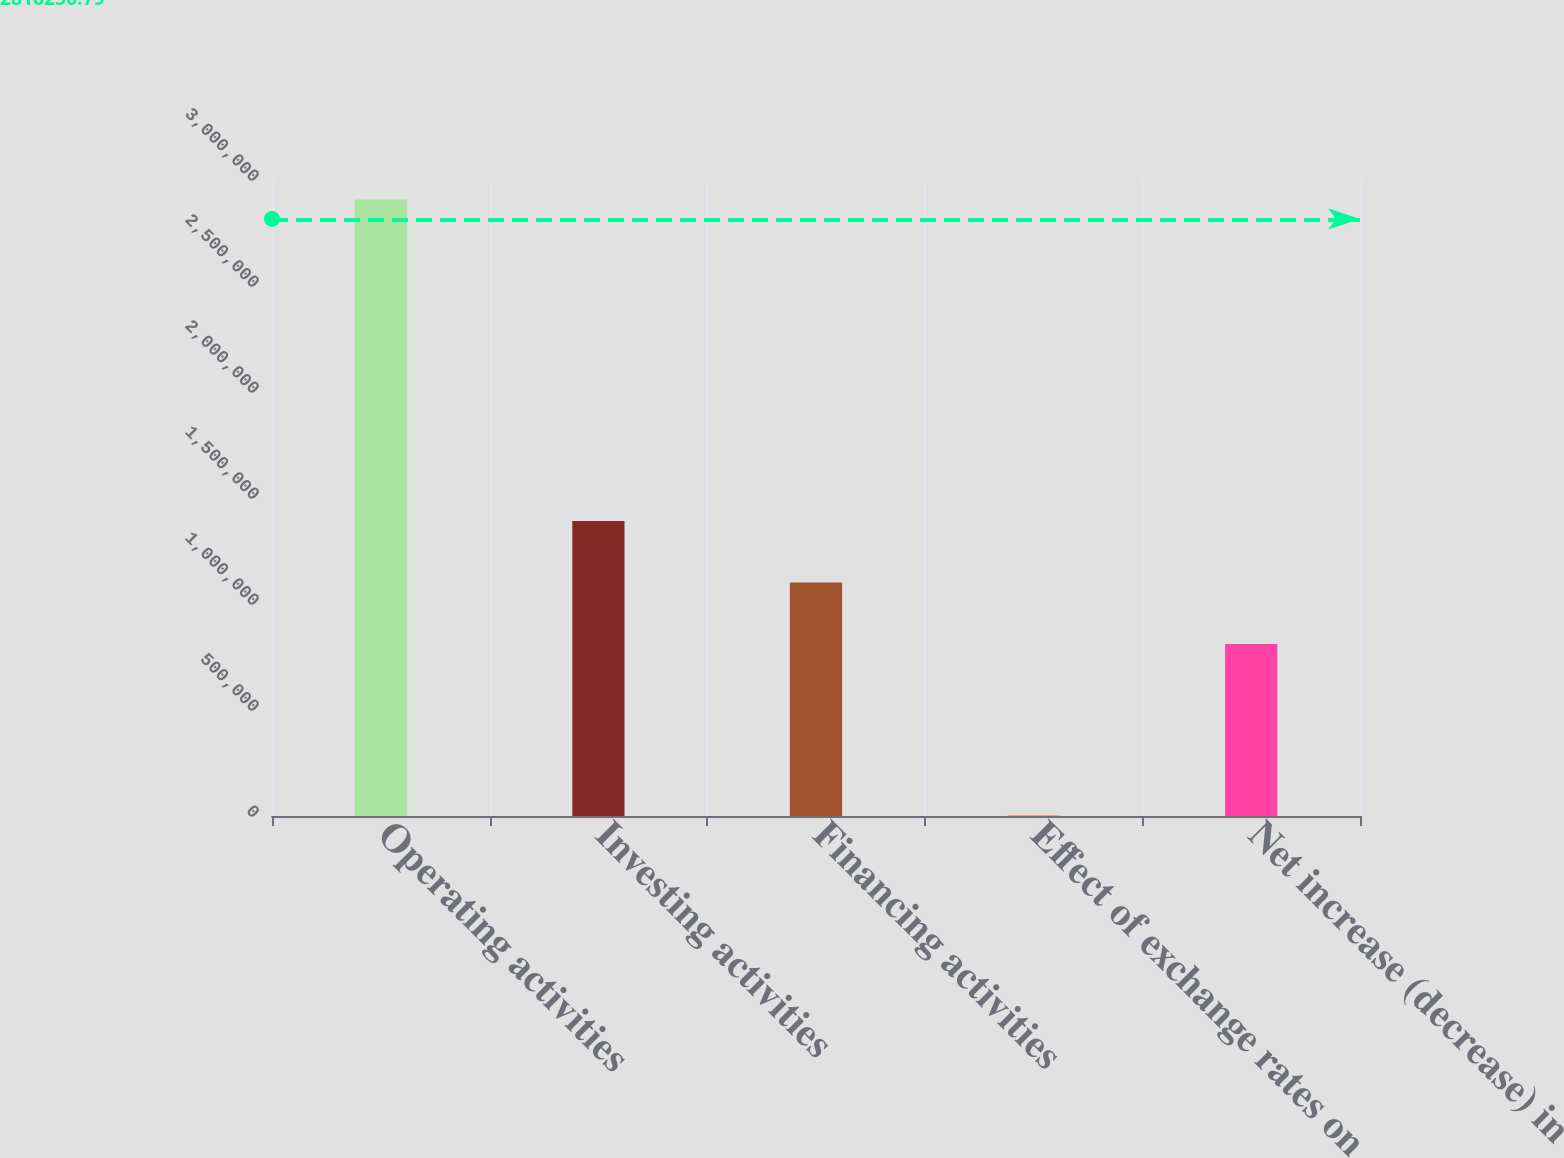<chart> <loc_0><loc_0><loc_500><loc_500><bar_chart><fcel>Operating activities<fcel>Investing activities<fcel>Financing activities<fcel>Effect of exchange rates on<fcel>Net increase (decrease) in<nl><fcel>2.90809e+06<fcel>1.39208e+06<fcel>1.10148e+06<fcel>2157<fcel>810890<nl></chart> 